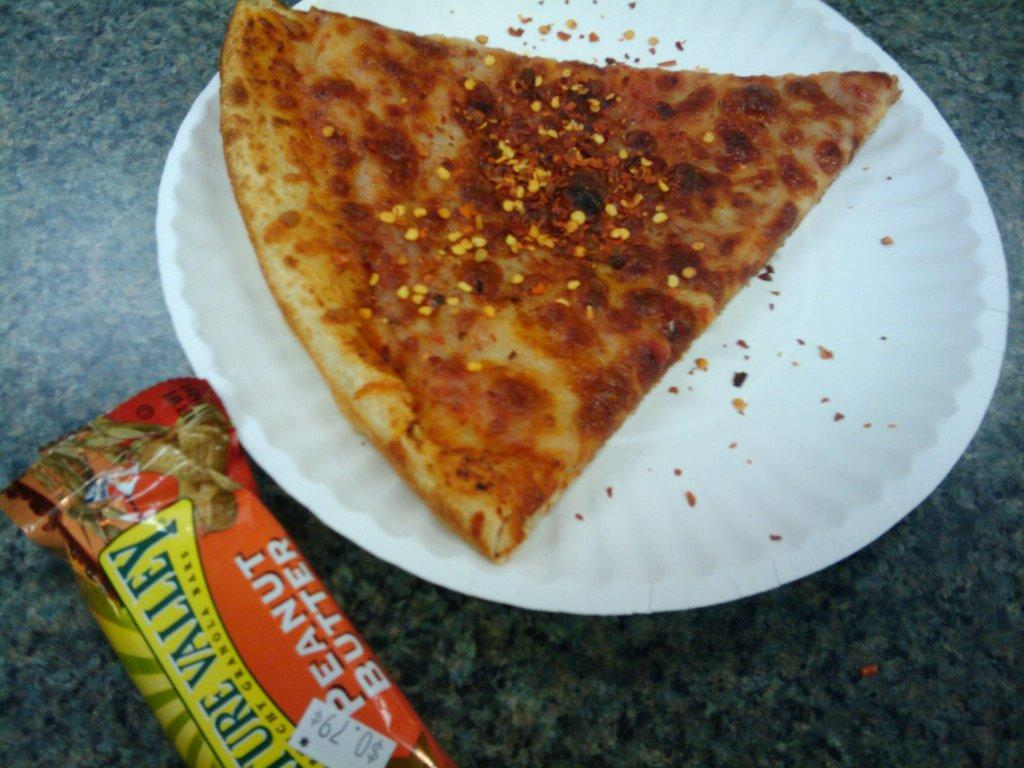What is on the plate in the image? There is a food item on a plate in the image. Where is the plate located? The plate is placed on a surface. What is beside the plate? There is a packet beside the plate. What can be seen on the packet? The packet has text on it. Can you play a guitar solo while holding the food item in the image? There is no guitar present in the image, and the food item is on a plate, so it is not possible to play a guitar solo while holding it. 